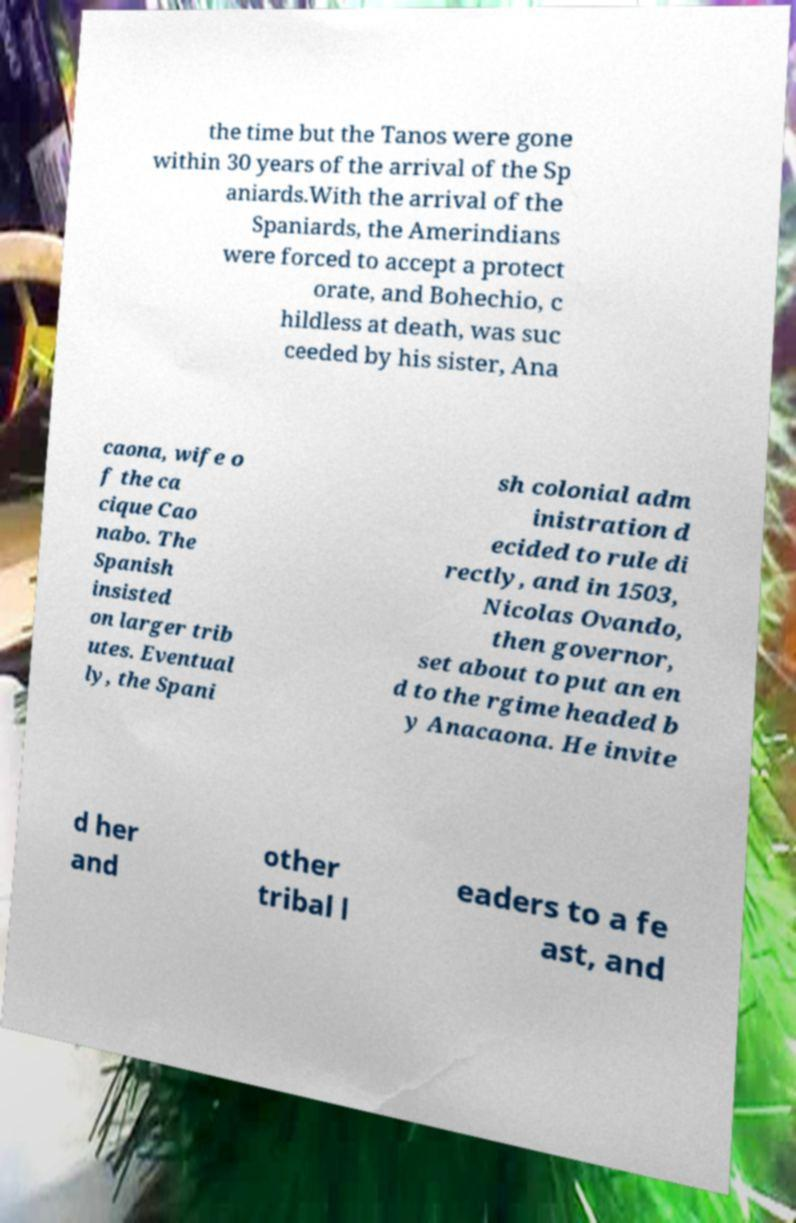Could you extract and type out the text from this image? the time but the Tanos were gone within 30 years of the arrival of the Sp aniards.With the arrival of the Spaniards, the Amerindians were forced to accept a protect orate, and Bohechio, c hildless at death, was suc ceeded by his sister, Ana caona, wife o f the ca cique Cao nabo. The Spanish insisted on larger trib utes. Eventual ly, the Spani sh colonial adm inistration d ecided to rule di rectly, and in 1503, Nicolas Ovando, then governor, set about to put an en d to the rgime headed b y Anacaona. He invite d her and other tribal l eaders to a fe ast, and 